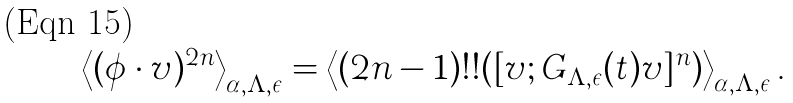Convert formula to latex. <formula><loc_0><loc_0><loc_500><loc_500>\left < ( \phi \cdot v ) ^ { 2 n } \right > _ { \alpha , \Lambda , \epsilon } = \left < ( 2 n - 1 ) ! ! ( [ v ; G _ { \Lambda , \epsilon } ( t ) v ] ^ { n } ) \right > _ { \alpha , \Lambda , \epsilon } .</formula> 